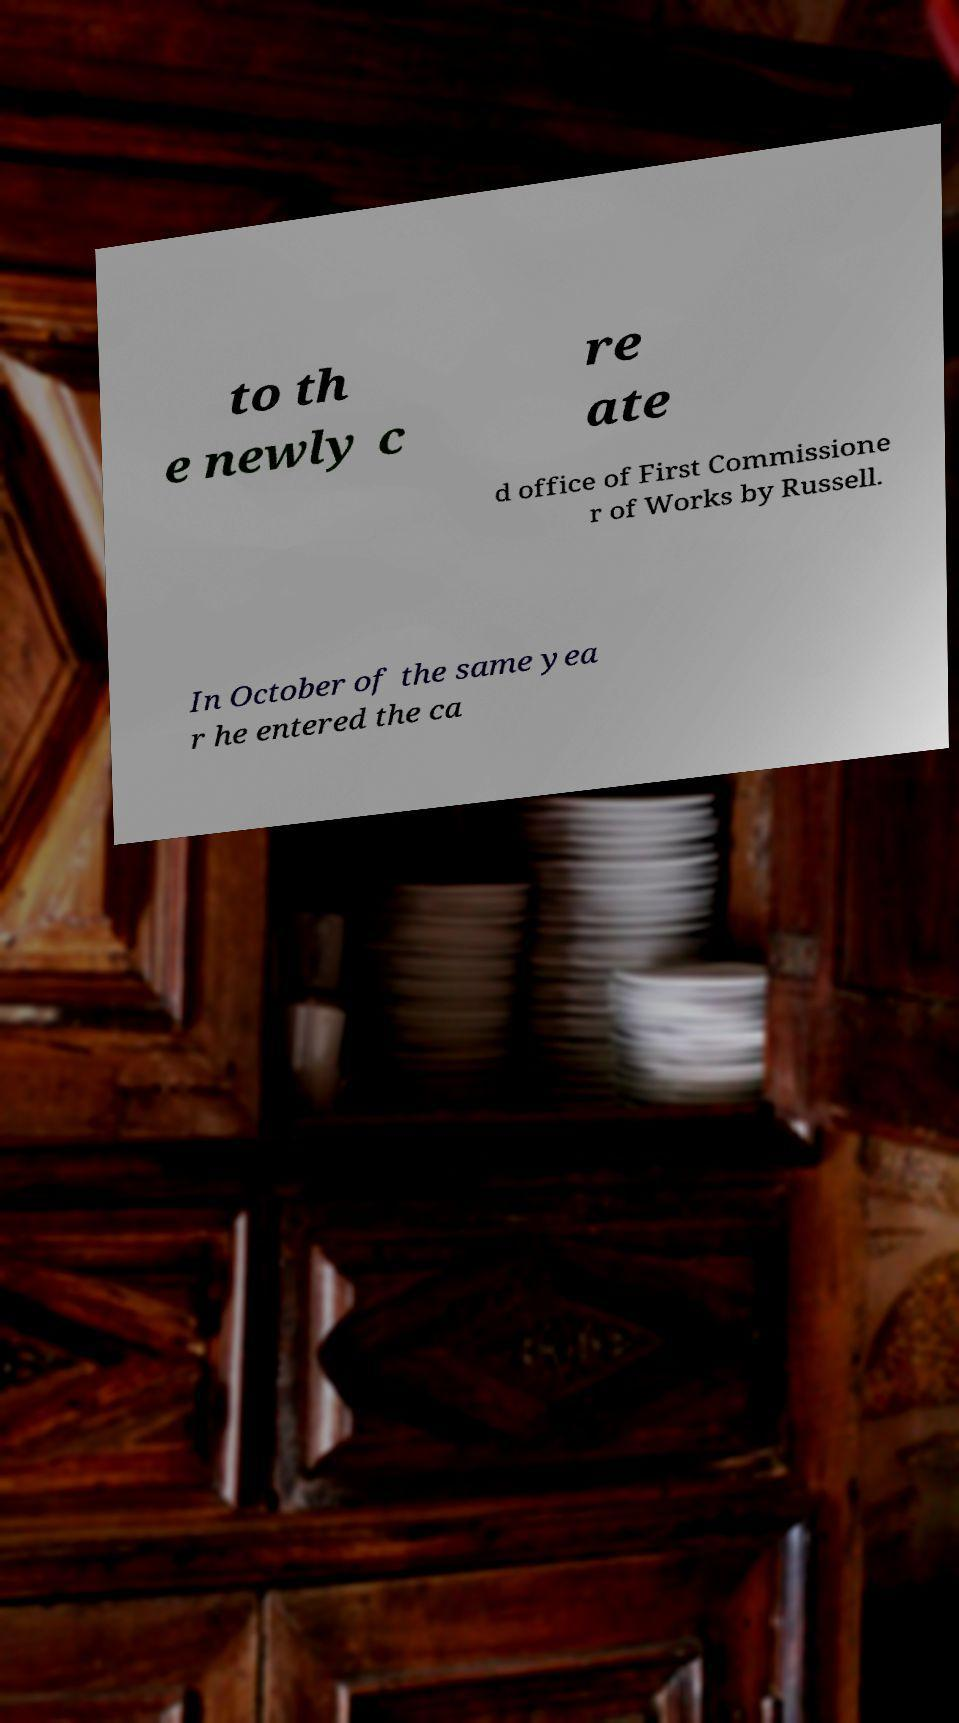Please read and relay the text visible in this image. What does it say? to th e newly c re ate d office of First Commissione r of Works by Russell. In October of the same yea r he entered the ca 